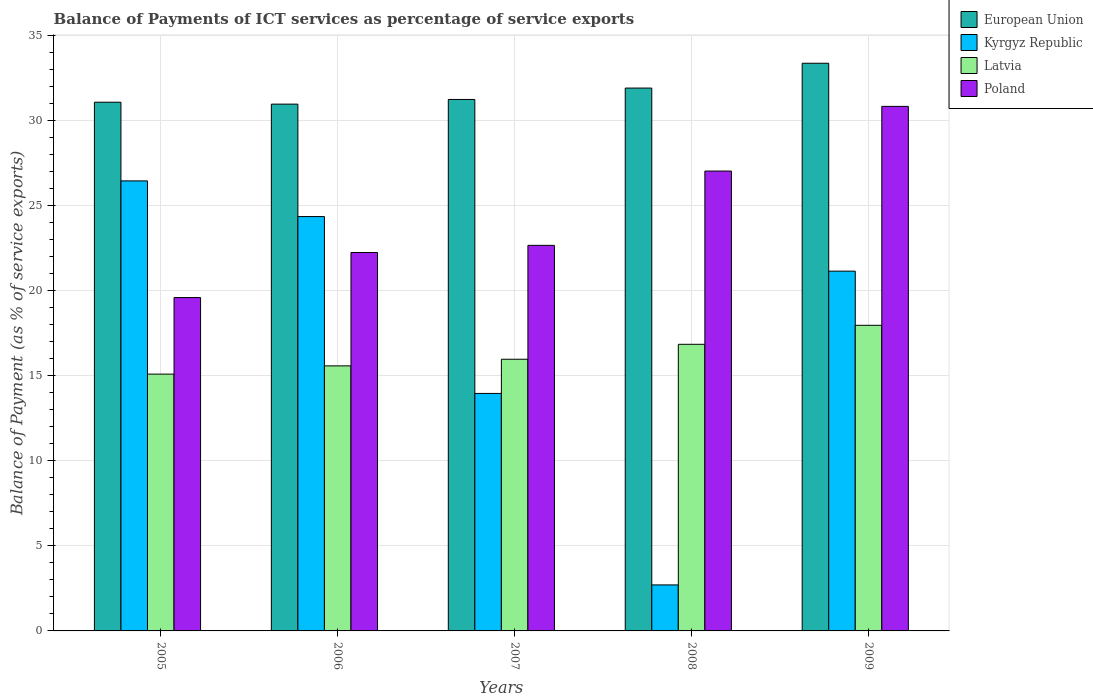How many groups of bars are there?
Make the answer very short. 5. Are the number of bars on each tick of the X-axis equal?
Ensure brevity in your answer.  Yes. How many bars are there on the 2nd tick from the left?
Your answer should be compact. 4. How many bars are there on the 1st tick from the right?
Give a very brief answer. 4. In how many cases, is the number of bars for a given year not equal to the number of legend labels?
Your answer should be compact. 0. What is the balance of payments of ICT services in European Union in 2007?
Your answer should be very brief. 31.23. Across all years, what is the maximum balance of payments of ICT services in Latvia?
Offer a very short reply. 17.96. Across all years, what is the minimum balance of payments of ICT services in Poland?
Offer a very short reply. 19.59. In which year was the balance of payments of ICT services in European Union maximum?
Ensure brevity in your answer.  2009. In which year was the balance of payments of ICT services in Poland minimum?
Provide a short and direct response. 2005. What is the total balance of payments of ICT services in European Union in the graph?
Your response must be concise. 158.52. What is the difference between the balance of payments of ICT services in European Union in 2006 and that in 2009?
Provide a short and direct response. -2.4. What is the difference between the balance of payments of ICT services in Kyrgyz Republic in 2008 and the balance of payments of ICT services in Poland in 2005?
Your answer should be very brief. -16.89. What is the average balance of payments of ICT services in Latvia per year?
Give a very brief answer. 16.29. In the year 2009, what is the difference between the balance of payments of ICT services in Kyrgyz Republic and balance of payments of ICT services in Latvia?
Your response must be concise. 3.18. What is the ratio of the balance of payments of ICT services in Latvia in 2006 to that in 2008?
Keep it short and to the point. 0.92. Is the balance of payments of ICT services in European Union in 2006 less than that in 2008?
Provide a succinct answer. Yes. Is the difference between the balance of payments of ICT services in Kyrgyz Republic in 2005 and 2007 greater than the difference between the balance of payments of ICT services in Latvia in 2005 and 2007?
Offer a very short reply. Yes. What is the difference between the highest and the second highest balance of payments of ICT services in Latvia?
Make the answer very short. 1.12. What is the difference between the highest and the lowest balance of payments of ICT services in Latvia?
Provide a short and direct response. 2.87. In how many years, is the balance of payments of ICT services in Latvia greater than the average balance of payments of ICT services in Latvia taken over all years?
Make the answer very short. 2. Is the sum of the balance of payments of ICT services in Latvia in 2005 and 2009 greater than the maximum balance of payments of ICT services in Kyrgyz Republic across all years?
Offer a terse response. Yes. What does the 2nd bar from the left in 2006 represents?
Your response must be concise. Kyrgyz Republic. How many years are there in the graph?
Your answer should be compact. 5. What is the difference between two consecutive major ticks on the Y-axis?
Offer a terse response. 5. Does the graph contain any zero values?
Keep it short and to the point. No. Where does the legend appear in the graph?
Make the answer very short. Top right. How are the legend labels stacked?
Make the answer very short. Vertical. What is the title of the graph?
Provide a short and direct response. Balance of Payments of ICT services as percentage of service exports. What is the label or title of the Y-axis?
Make the answer very short. Balance of Payment (as % of service exports). What is the Balance of Payment (as % of service exports) of European Union in 2005?
Ensure brevity in your answer.  31.07. What is the Balance of Payment (as % of service exports) of Kyrgyz Republic in 2005?
Your answer should be compact. 26.45. What is the Balance of Payment (as % of service exports) of Latvia in 2005?
Provide a succinct answer. 15.09. What is the Balance of Payment (as % of service exports) of Poland in 2005?
Offer a terse response. 19.59. What is the Balance of Payment (as % of service exports) of European Union in 2006?
Your answer should be compact. 30.96. What is the Balance of Payment (as % of service exports) in Kyrgyz Republic in 2006?
Offer a terse response. 24.35. What is the Balance of Payment (as % of service exports) of Latvia in 2006?
Give a very brief answer. 15.58. What is the Balance of Payment (as % of service exports) in Poland in 2006?
Provide a succinct answer. 22.24. What is the Balance of Payment (as % of service exports) of European Union in 2007?
Your answer should be compact. 31.23. What is the Balance of Payment (as % of service exports) of Kyrgyz Republic in 2007?
Keep it short and to the point. 13.96. What is the Balance of Payment (as % of service exports) in Latvia in 2007?
Offer a terse response. 15.97. What is the Balance of Payment (as % of service exports) of Poland in 2007?
Your answer should be compact. 22.66. What is the Balance of Payment (as % of service exports) in European Union in 2008?
Keep it short and to the point. 31.9. What is the Balance of Payment (as % of service exports) in Kyrgyz Republic in 2008?
Offer a very short reply. 2.7. What is the Balance of Payment (as % of service exports) of Latvia in 2008?
Your answer should be very brief. 16.84. What is the Balance of Payment (as % of service exports) in Poland in 2008?
Make the answer very short. 27.02. What is the Balance of Payment (as % of service exports) in European Union in 2009?
Provide a short and direct response. 33.36. What is the Balance of Payment (as % of service exports) in Kyrgyz Republic in 2009?
Provide a short and direct response. 21.14. What is the Balance of Payment (as % of service exports) in Latvia in 2009?
Provide a succinct answer. 17.96. What is the Balance of Payment (as % of service exports) in Poland in 2009?
Ensure brevity in your answer.  30.82. Across all years, what is the maximum Balance of Payment (as % of service exports) in European Union?
Keep it short and to the point. 33.36. Across all years, what is the maximum Balance of Payment (as % of service exports) in Kyrgyz Republic?
Provide a succinct answer. 26.45. Across all years, what is the maximum Balance of Payment (as % of service exports) in Latvia?
Keep it short and to the point. 17.96. Across all years, what is the maximum Balance of Payment (as % of service exports) of Poland?
Make the answer very short. 30.82. Across all years, what is the minimum Balance of Payment (as % of service exports) of European Union?
Offer a very short reply. 30.96. Across all years, what is the minimum Balance of Payment (as % of service exports) of Kyrgyz Republic?
Ensure brevity in your answer.  2.7. Across all years, what is the minimum Balance of Payment (as % of service exports) of Latvia?
Keep it short and to the point. 15.09. Across all years, what is the minimum Balance of Payment (as % of service exports) of Poland?
Offer a very short reply. 19.59. What is the total Balance of Payment (as % of service exports) of European Union in the graph?
Give a very brief answer. 158.52. What is the total Balance of Payment (as % of service exports) in Kyrgyz Republic in the graph?
Give a very brief answer. 88.6. What is the total Balance of Payment (as % of service exports) of Latvia in the graph?
Provide a succinct answer. 81.44. What is the total Balance of Payment (as % of service exports) in Poland in the graph?
Keep it short and to the point. 122.34. What is the difference between the Balance of Payment (as % of service exports) in European Union in 2005 and that in 2006?
Offer a very short reply. 0.11. What is the difference between the Balance of Payment (as % of service exports) in Kyrgyz Republic in 2005 and that in 2006?
Give a very brief answer. 2.1. What is the difference between the Balance of Payment (as % of service exports) in Latvia in 2005 and that in 2006?
Offer a very short reply. -0.48. What is the difference between the Balance of Payment (as % of service exports) in Poland in 2005 and that in 2006?
Your answer should be very brief. -2.65. What is the difference between the Balance of Payment (as % of service exports) in European Union in 2005 and that in 2007?
Your response must be concise. -0.16. What is the difference between the Balance of Payment (as % of service exports) in Kyrgyz Republic in 2005 and that in 2007?
Ensure brevity in your answer.  12.49. What is the difference between the Balance of Payment (as % of service exports) of Latvia in 2005 and that in 2007?
Ensure brevity in your answer.  -0.87. What is the difference between the Balance of Payment (as % of service exports) of Poland in 2005 and that in 2007?
Your answer should be very brief. -3.07. What is the difference between the Balance of Payment (as % of service exports) of European Union in 2005 and that in 2008?
Provide a succinct answer. -0.83. What is the difference between the Balance of Payment (as % of service exports) of Kyrgyz Republic in 2005 and that in 2008?
Ensure brevity in your answer.  23.74. What is the difference between the Balance of Payment (as % of service exports) of Latvia in 2005 and that in 2008?
Make the answer very short. -1.75. What is the difference between the Balance of Payment (as % of service exports) of Poland in 2005 and that in 2008?
Give a very brief answer. -7.43. What is the difference between the Balance of Payment (as % of service exports) in European Union in 2005 and that in 2009?
Provide a short and direct response. -2.29. What is the difference between the Balance of Payment (as % of service exports) of Kyrgyz Republic in 2005 and that in 2009?
Your answer should be very brief. 5.3. What is the difference between the Balance of Payment (as % of service exports) of Latvia in 2005 and that in 2009?
Provide a succinct answer. -2.87. What is the difference between the Balance of Payment (as % of service exports) of Poland in 2005 and that in 2009?
Your response must be concise. -11.23. What is the difference between the Balance of Payment (as % of service exports) in European Union in 2006 and that in 2007?
Keep it short and to the point. -0.27. What is the difference between the Balance of Payment (as % of service exports) in Kyrgyz Republic in 2006 and that in 2007?
Give a very brief answer. 10.39. What is the difference between the Balance of Payment (as % of service exports) in Latvia in 2006 and that in 2007?
Offer a very short reply. -0.39. What is the difference between the Balance of Payment (as % of service exports) in Poland in 2006 and that in 2007?
Ensure brevity in your answer.  -0.42. What is the difference between the Balance of Payment (as % of service exports) in European Union in 2006 and that in 2008?
Ensure brevity in your answer.  -0.94. What is the difference between the Balance of Payment (as % of service exports) in Kyrgyz Republic in 2006 and that in 2008?
Make the answer very short. 21.65. What is the difference between the Balance of Payment (as % of service exports) of Latvia in 2006 and that in 2008?
Make the answer very short. -1.27. What is the difference between the Balance of Payment (as % of service exports) of Poland in 2006 and that in 2008?
Provide a succinct answer. -4.79. What is the difference between the Balance of Payment (as % of service exports) of European Union in 2006 and that in 2009?
Your answer should be very brief. -2.4. What is the difference between the Balance of Payment (as % of service exports) of Kyrgyz Republic in 2006 and that in 2009?
Provide a short and direct response. 3.21. What is the difference between the Balance of Payment (as % of service exports) in Latvia in 2006 and that in 2009?
Give a very brief answer. -2.38. What is the difference between the Balance of Payment (as % of service exports) in Poland in 2006 and that in 2009?
Provide a short and direct response. -8.59. What is the difference between the Balance of Payment (as % of service exports) of European Union in 2007 and that in 2008?
Give a very brief answer. -0.67. What is the difference between the Balance of Payment (as % of service exports) in Kyrgyz Republic in 2007 and that in 2008?
Give a very brief answer. 11.25. What is the difference between the Balance of Payment (as % of service exports) of Latvia in 2007 and that in 2008?
Ensure brevity in your answer.  -0.88. What is the difference between the Balance of Payment (as % of service exports) in Poland in 2007 and that in 2008?
Give a very brief answer. -4.37. What is the difference between the Balance of Payment (as % of service exports) of European Union in 2007 and that in 2009?
Your answer should be very brief. -2.13. What is the difference between the Balance of Payment (as % of service exports) of Kyrgyz Republic in 2007 and that in 2009?
Offer a terse response. -7.19. What is the difference between the Balance of Payment (as % of service exports) of Latvia in 2007 and that in 2009?
Your answer should be compact. -1.99. What is the difference between the Balance of Payment (as % of service exports) in Poland in 2007 and that in 2009?
Offer a very short reply. -8.17. What is the difference between the Balance of Payment (as % of service exports) in European Union in 2008 and that in 2009?
Give a very brief answer. -1.46. What is the difference between the Balance of Payment (as % of service exports) of Kyrgyz Republic in 2008 and that in 2009?
Your response must be concise. -18.44. What is the difference between the Balance of Payment (as % of service exports) in Latvia in 2008 and that in 2009?
Keep it short and to the point. -1.12. What is the difference between the Balance of Payment (as % of service exports) in Poland in 2008 and that in 2009?
Offer a very short reply. -3.8. What is the difference between the Balance of Payment (as % of service exports) of European Union in 2005 and the Balance of Payment (as % of service exports) of Kyrgyz Republic in 2006?
Make the answer very short. 6.72. What is the difference between the Balance of Payment (as % of service exports) in European Union in 2005 and the Balance of Payment (as % of service exports) in Latvia in 2006?
Make the answer very short. 15.49. What is the difference between the Balance of Payment (as % of service exports) in European Union in 2005 and the Balance of Payment (as % of service exports) in Poland in 2006?
Ensure brevity in your answer.  8.83. What is the difference between the Balance of Payment (as % of service exports) of Kyrgyz Republic in 2005 and the Balance of Payment (as % of service exports) of Latvia in 2006?
Offer a very short reply. 10.87. What is the difference between the Balance of Payment (as % of service exports) of Kyrgyz Republic in 2005 and the Balance of Payment (as % of service exports) of Poland in 2006?
Provide a succinct answer. 4.21. What is the difference between the Balance of Payment (as % of service exports) in Latvia in 2005 and the Balance of Payment (as % of service exports) in Poland in 2006?
Provide a succinct answer. -7.15. What is the difference between the Balance of Payment (as % of service exports) of European Union in 2005 and the Balance of Payment (as % of service exports) of Kyrgyz Republic in 2007?
Provide a succinct answer. 17.11. What is the difference between the Balance of Payment (as % of service exports) of European Union in 2005 and the Balance of Payment (as % of service exports) of Latvia in 2007?
Offer a very short reply. 15.1. What is the difference between the Balance of Payment (as % of service exports) of European Union in 2005 and the Balance of Payment (as % of service exports) of Poland in 2007?
Ensure brevity in your answer.  8.41. What is the difference between the Balance of Payment (as % of service exports) of Kyrgyz Republic in 2005 and the Balance of Payment (as % of service exports) of Latvia in 2007?
Provide a succinct answer. 10.48. What is the difference between the Balance of Payment (as % of service exports) of Kyrgyz Republic in 2005 and the Balance of Payment (as % of service exports) of Poland in 2007?
Provide a short and direct response. 3.79. What is the difference between the Balance of Payment (as % of service exports) in Latvia in 2005 and the Balance of Payment (as % of service exports) in Poland in 2007?
Your answer should be very brief. -7.57. What is the difference between the Balance of Payment (as % of service exports) in European Union in 2005 and the Balance of Payment (as % of service exports) in Kyrgyz Republic in 2008?
Provide a short and direct response. 28.37. What is the difference between the Balance of Payment (as % of service exports) of European Union in 2005 and the Balance of Payment (as % of service exports) of Latvia in 2008?
Provide a short and direct response. 14.23. What is the difference between the Balance of Payment (as % of service exports) in European Union in 2005 and the Balance of Payment (as % of service exports) in Poland in 2008?
Provide a succinct answer. 4.05. What is the difference between the Balance of Payment (as % of service exports) in Kyrgyz Republic in 2005 and the Balance of Payment (as % of service exports) in Latvia in 2008?
Your response must be concise. 9.6. What is the difference between the Balance of Payment (as % of service exports) of Kyrgyz Republic in 2005 and the Balance of Payment (as % of service exports) of Poland in 2008?
Offer a terse response. -0.58. What is the difference between the Balance of Payment (as % of service exports) of Latvia in 2005 and the Balance of Payment (as % of service exports) of Poland in 2008?
Your answer should be very brief. -11.93. What is the difference between the Balance of Payment (as % of service exports) in European Union in 2005 and the Balance of Payment (as % of service exports) in Kyrgyz Republic in 2009?
Offer a very short reply. 9.93. What is the difference between the Balance of Payment (as % of service exports) of European Union in 2005 and the Balance of Payment (as % of service exports) of Latvia in 2009?
Offer a terse response. 13.11. What is the difference between the Balance of Payment (as % of service exports) in European Union in 2005 and the Balance of Payment (as % of service exports) in Poland in 2009?
Provide a short and direct response. 0.25. What is the difference between the Balance of Payment (as % of service exports) of Kyrgyz Republic in 2005 and the Balance of Payment (as % of service exports) of Latvia in 2009?
Offer a terse response. 8.49. What is the difference between the Balance of Payment (as % of service exports) of Kyrgyz Republic in 2005 and the Balance of Payment (as % of service exports) of Poland in 2009?
Provide a short and direct response. -4.38. What is the difference between the Balance of Payment (as % of service exports) in Latvia in 2005 and the Balance of Payment (as % of service exports) in Poland in 2009?
Ensure brevity in your answer.  -15.73. What is the difference between the Balance of Payment (as % of service exports) in European Union in 2006 and the Balance of Payment (as % of service exports) in Kyrgyz Republic in 2007?
Your response must be concise. 17. What is the difference between the Balance of Payment (as % of service exports) in European Union in 2006 and the Balance of Payment (as % of service exports) in Latvia in 2007?
Ensure brevity in your answer.  14.99. What is the difference between the Balance of Payment (as % of service exports) in European Union in 2006 and the Balance of Payment (as % of service exports) in Poland in 2007?
Make the answer very short. 8.3. What is the difference between the Balance of Payment (as % of service exports) of Kyrgyz Republic in 2006 and the Balance of Payment (as % of service exports) of Latvia in 2007?
Provide a short and direct response. 8.38. What is the difference between the Balance of Payment (as % of service exports) of Kyrgyz Republic in 2006 and the Balance of Payment (as % of service exports) of Poland in 2007?
Ensure brevity in your answer.  1.69. What is the difference between the Balance of Payment (as % of service exports) of Latvia in 2006 and the Balance of Payment (as % of service exports) of Poland in 2007?
Ensure brevity in your answer.  -7.08. What is the difference between the Balance of Payment (as % of service exports) of European Union in 2006 and the Balance of Payment (as % of service exports) of Kyrgyz Republic in 2008?
Make the answer very short. 28.25. What is the difference between the Balance of Payment (as % of service exports) of European Union in 2006 and the Balance of Payment (as % of service exports) of Latvia in 2008?
Your answer should be compact. 14.11. What is the difference between the Balance of Payment (as % of service exports) in European Union in 2006 and the Balance of Payment (as % of service exports) in Poland in 2008?
Offer a very short reply. 3.93. What is the difference between the Balance of Payment (as % of service exports) of Kyrgyz Republic in 2006 and the Balance of Payment (as % of service exports) of Latvia in 2008?
Provide a short and direct response. 7.51. What is the difference between the Balance of Payment (as % of service exports) of Kyrgyz Republic in 2006 and the Balance of Payment (as % of service exports) of Poland in 2008?
Your response must be concise. -2.68. What is the difference between the Balance of Payment (as % of service exports) in Latvia in 2006 and the Balance of Payment (as % of service exports) in Poland in 2008?
Ensure brevity in your answer.  -11.45. What is the difference between the Balance of Payment (as % of service exports) of European Union in 2006 and the Balance of Payment (as % of service exports) of Kyrgyz Republic in 2009?
Keep it short and to the point. 9.81. What is the difference between the Balance of Payment (as % of service exports) of European Union in 2006 and the Balance of Payment (as % of service exports) of Latvia in 2009?
Offer a terse response. 13. What is the difference between the Balance of Payment (as % of service exports) in European Union in 2006 and the Balance of Payment (as % of service exports) in Poland in 2009?
Provide a succinct answer. 0.13. What is the difference between the Balance of Payment (as % of service exports) in Kyrgyz Republic in 2006 and the Balance of Payment (as % of service exports) in Latvia in 2009?
Your response must be concise. 6.39. What is the difference between the Balance of Payment (as % of service exports) in Kyrgyz Republic in 2006 and the Balance of Payment (as % of service exports) in Poland in 2009?
Give a very brief answer. -6.48. What is the difference between the Balance of Payment (as % of service exports) in Latvia in 2006 and the Balance of Payment (as % of service exports) in Poland in 2009?
Provide a succinct answer. -15.25. What is the difference between the Balance of Payment (as % of service exports) in European Union in 2007 and the Balance of Payment (as % of service exports) in Kyrgyz Republic in 2008?
Provide a short and direct response. 28.53. What is the difference between the Balance of Payment (as % of service exports) of European Union in 2007 and the Balance of Payment (as % of service exports) of Latvia in 2008?
Make the answer very short. 14.39. What is the difference between the Balance of Payment (as % of service exports) in European Union in 2007 and the Balance of Payment (as % of service exports) in Poland in 2008?
Provide a short and direct response. 4.21. What is the difference between the Balance of Payment (as % of service exports) in Kyrgyz Republic in 2007 and the Balance of Payment (as % of service exports) in Latvia in 2008?
Offer a terse response. -2.89. What is the difference between the Balance of Payment (as % of service exports) of Kyrgyz Republic in 2007 and the Balance of Payment (as % of service exports) of Poland in 2008?
Provide a succinct answer. -13.07. What is the difference between the Balance of Payment (as % of service exports) of Latvia in 2007 and the Balance of Payment (as % of service exports) of Poland in 2008?
Your response must be concise. -11.06. What is the difference between the Balance of Payment (as % of service exports) of European Union in 2007 and the Balance of Payment (as % of service exports) of Kyrgyz Republic in 2009?
Give a very brief answer. 10.09. What is the difference between the Balance of Payment (as % of service exports) of European Union in 2007 and the Balance of Payment (as % of service exports) of Latvia in 2009?
Provide a succinct answer. 13.27. What is the difference between the Balance of Payment (as % of service exports) in European Union in 2007 and the Balance of Payment (as % of service exports) in Poland in 2009?
Ensure brevity in your answer.  0.41. What is the difference between the Balance of Payment (as % of service exports) of Kyrgyz Republic in 2007 and the Balance of Payment (as % of service exports) of Latvia in 2009?
Offer a very short reply. -4. What is the difference between the Balance of Payment (as % of service exports) in Kyrgyz Republic in 2007 and the Balance of Payment (as % of service exports) in Poland in 2009?
Give a very brief answer. -16.87. What is the difference between the Balance of Payment (as % of service exports) of Latvia in 2007 and the Balance of Payment (as % of service exports) of Poland in 2009?
Your answer should be very brief. -14.86. What is the difference between the Balance of Payment (as % of service exports) of European Union in 2008 and the Balance of Payment (as % of service exports) of Kyrgyz Republic in 2009?
Ensure brevity in your answer.  10.76. What is the difference between the Balance of Payment (as % of service exports) of European Union in 2008 and the Balance of Payment (as % of service exports) of Latvia in 2009?
Provide a succinct answer. 13.94. What is the difference between the Balance of Payment (as % of service exports) of European Union in 2008 and the Balance of Payment (as % of service exports) of Poland in 2009?
Offer a very short reply. 1.08. What is the difference between the Balance of Payment (as % of service exports) in Kyrgyz Republic in 2008 and the Balance of Payment (as % of service exports) in Latvia in 2009?
Your answer should be compact. -15.26. What is the difference between the Balance of Payment (as % of service exports) of Kyrgyz Republic in 2008 and the Balance of Payment (as % of service exports) of Poland in 2009?
Ensure brevity in your answer.  -28.12. What is the difference between the Balance of Payment (as % of service exports) of Latvia in 2008 and the Balance of Payment (as % of service exports) of Poland in 2009?
Provide a short and direct response. -13.98. What is the average Balance of Payment (as % of service exports) of European Union per year?
Your answer should be very brief. 31.7. What is the average Balance of Payment (as % of service exports) of Kyrgyz Republic per year?
Your answer should be very brief. 17.72. What is the average Balance of Payment (as % of service exports) of Latvia per year?
Provide a short and direct response. 16.29. What is the average Balance of Payment (as % of service exports) of Poland per year?
Your answer should be compact. 24.47. In the year 2005, what is the difference between the Balance of Payment (as % of service exports) in European Union and Balance of Payment (as % of service exports) in Kyrgyz Republic?
Your response must be concise. 4.62. In the year 2005, what is the difference between the Balance of Payment (as % of service exports) of European Union and Balance of Payment (as % of service exports) of Latvia?
Your answer should be very brief. 15.98. In the year 2005, what is the difference between the Balance of Payment (as % of service exports) in European Union and Balance of Payment (as % of service exports) in Poland?
Offer a very short reply. 11.48. In the year 2005, what is the difference between the Balance of Payment (as % of service exports) of Kyrgyz Republic and Balance of Payment (as % of service exports) of Latvia?
Ensure brevity in your answer.  11.35. In the year 2005, what is the difference between the Balance of Payment (as % of service exports) of Kyrgyz Republic and Balance of Payment (as % of service exports) of Poland?
Keep it short and to the point. 6.86. In the year 2005, what is the difference between the Balance of Payment (as % of service exports) of Latvia and Balance of Payment (as % of service exports) of Poland?
Your answer should be very brief. -4.5. In the year 2006, what is the difference between the Balance of Payment (as % of service exports) of European Union and Balance of Payment (as % of service exports) of Kyrgyz Republic?
Provide a succinct answer. 6.61. In the year 2006, what is the difference between the Balance of Payment (as % of service exports) of European Union and Balance of Payment (as % of service exports) of Latvia?
Offer a terse response. 15.38. In the year 2006, what is the difference between the Balance of Payment (as % of service exports) in European Union and Balance of Payment (as % of service exports) in Poland?
Provide a succinct answer. 8.72. In the year 2006, what is the difference between the Balance of Payment (as % of service exports) in Kyrgyz Republic and Balance of Payment (as % of service exports) in Latvia?
Keep it short and to the point. 8.77. In the year 2006, what is the difference between the Balance of Payment (as % of service exports) of Kyrgyz Republic and Balance of Payment (as % of service exports) of Poland?
Ensure brevity in your answer.  2.11. In the year 2006, what is the difference between the Balance of Payment (as % of service exports) of Latvia and Balance of Payment (as % of service exports) of Poland?
Your answer should be compact. -6.66. In the year 2007, what is the difference between the Balance of Payment (as % of service exports) of European Union and Balance of Payment (as % of service exports) of Kyrgyz Republic?
Your answer should be very brief. 17.27. In the year 2007, what is the difference between the Balance of Payment (as % of service exports) of European Union and Balance of Payment (as % of service exports) of Latvia?
Offer a very short reply. 15.27. In the year 2007, what is the difference between the Balance of Payment (as % of service exports) in European Union and Balance of Payment (as % of service exports) in Poland?
Your answer should be compact. 8.57. In the year 2007, what is the difference between the Balance of Payment (as % of service exports) in Kyrgyz Republic and Balance of Payment (as % of service exports) in Latvia?
Your answer should be compact. -2.01. In the year 2007, what is the difference between the Balance of Payment (as % of service exports) in Kyrgyz Republic and Balance of Payment (as % of service exports) in Poland?
Give a very brief answer. -8.7. In the year 2007, what is the difference between the Balance of Payment (as % of service exports) of Latvia and Balance of Payment (as % of service exports) of Poland?
Ensure brevity in your answer.  -6.69. In the year 2008, what is the difference between the Balance of Payment (as % of service exports) of European Union and Balance of Payment (as % of service exports) of Kyrgyz Republic?
Provide a succinct answer. 29.2. In the year 2008, what is the difference between the Balance of Payment (as % of service exports) of European Union and Balance of Payment (as % of service exports) of Latvia?
Your answer should be very brief. 15.06. In the year 2008, what is the difference between the Balance of Payment (as % of service exports) in European Union and Balance of Payment (as % of service exports) in Poland?
Ensure brevity in your answer.  4.88. In the year 2008, what is the difference between the Balance of Payment (as % of service exports) of Kyrgyz Republic and Balance of Payment (as % of service exports) of Latvia?
Make the answer very short. -14.14. In the year 2008, what is the difference between the Balance of Payment (as % of service exports) of Kyrgyz Republic and Balance of Payment (as % of service exports) of Poland?
Your response must be concise. -24.32. In the year 2008, what is the difference between the Balance of Payment (as % of service exports) in Latvia and Balance of Payment (as % of service exports) in Poland?
Make the answer very short. -10.18. In the year 2009, what is the difference between the Balance of Payment (as % of service exports) in European Union and Balance of Payment (as % of service exports) in Kyrgyz Republic?
Offer a very short reply. 12.22. In the year 2009, what is the difference between the Balance of Payment (as % of service exports) in European Union and Balance of Payment (as % of service exports) in Latvia?
Give a very brief answer. 15.4. In the year 2009, what is the difference between the Balance of Payment (as % of service exports) in European Union and Balance of Payment (as % of service exports) in Poland?
Offer a very short reply. 2.53. In the year 2009, what is the difference between the Balance of Payment (as % of service exports) in Kyrgyz Republic and Balance of Payment (as % of service exports) in Latvia?
Keep it short and to the point. 3.18. In the year 2009, what is the difference between the Balance of Payment (as % of service exports) in Kyrgyz Republic and Balance of Payment (as % of service exports) in Poland?
Give a very brief answer. -9.68. In the year 2009, what is the difference between the Balance of Payment (as % of service exports) in Latvia and Balance of Payment (as % of service exports) in Poland?
Give a very brief answer. -12.86. What is the ratio of the Balance of Payment (as % of service exports) in Kyrgyz Republic in 2005 to that in 2006?
Offer a terse response. 1.09. What is the ratio of the Balance of Payment (as % of service exports) in Latvia in 2005 to that in 2006?
Offer a terse response. 0.97. What is the ratio of the Balance of Payment (as % of service exports) in Poland in 2005 to that in 2006?
Give a very brief answer. 0.88. What is the ratio of the Balance of Payment (as % of service exports) of Kyrgyz Republic in 2005 to that in 2007?
Provide a short and direct response. 1.89. What is the ratio of the Balance of Payment (as % of service exports) of Latvia in 2005 to that in 2007?
Your response must be concise. 0.95. What is the ratio of the Balance of Payment (as % of service exports) in Poland in 2005 to that in 2007?
Provide a short and direct response. 0.86. What is the ratio of the Balance of Payment (as % of service exports) of Kyrgyz Republic in 2005 to that in 2008?
Offer a terse response. 9.78. What is the ratio of the Balance of Payment (as % of service exports) of Latvia in 2005 to that in 2008?
Keep it short and to the point. 0.9. What is the ratio of the Balance of Payment (as % of service exports) of Poland in 2005 to that in 2008?
Provide a succinct answer. 0.72. What is the ratio of the Balance of Payment (as % of service exports) in European Union in 2005 to that in 2009?
Offer a terse response. 0.93. What is the ratio of the Balance of Payment (as % of service exports) of Kyrgyz Republic in 2005 to that in 2009?
Offer a terse response. 1.25. What is the ratio of the Balance of Payment (as % of service exports) in Latvia in 2005 to that in 2009?
Your answer should be compact. 0.84. What is the ratio of the Balance of Payment (as % of service exports) of Poland in 2005 to that in 2009?
Your response must be concise. 0.64. What is the ratio of the Balance of Payment (as % of service exports) in Kyrgyz Republic in 2006 to that in 2007?
Your response must be concise. 1.74. What is the ratio of the Balance of Payment (as % of service exports) of Latvia in 2006 to that in 2007?
Offer a very short reply. 0.98. What is the ratio of the Balance of Payment (as % of service exports) in Poland in 2006 to that in 2007?
Provide a short and direct response. 0.98. What is the ratio of the Balance of Payment (as % of service exports) of European Union in 2006 to that in 2008?
Your response must be concise. 0.97. What is the ratio of the Balance of Payment (as % of service exports) of Kyrgyz Republic in 2006 to that in 2008?
Offer a very short reply. 9.01. What is the ratio of the Balance of Payment (as % of service exports) of Latvia in 2006 to that in 2008?
Provide a short and direct response. 0.92. What is the ratio of the Balance of Payment (as % of service exports) in Poland in 2006 to that in 2008?
Provide a short and direct response. 0.82. What is the ratio of the Balance of Payment (as % of service exports) in European Union in 2006 to that in 2009?
Ensure brevity in your answer.  0.93. What is the ratio of the Balance of Payment (as % of service exports) of Kyrgyz Republic in 2006 to that in 2009?
Give a very brief answer. 1.15. What is the ratio of the Balance of Payment (as % of service exports) in Latvia in 2006 to that in 2009?
Make the answer very short. 0.87. What is the ratio of the Balance of Payment (as % of service exports) in Poland in 2006 to that in 2009?
Ensure brevity in your answer.  0.72. What is the ratio of the Balance of Payment (as % of service exports) in European Union in 2007 to that in 2008?
Your answer should be very brief. 0.98. What is the ratio of the Balance of Payment (as % of service exports) of Kyrgyz Republic in 2007 to that in 2008?
Provide a short and direct response. 5.16. What is the ratio of the Balance of Payment (as % of service exports) in Latvia in 2007 to that in 2008?
Provide a short and direct response. 0.95. What is the ratio of the Balance of Payment (as % of service exports) of Poland in 2007 to that in 2008?
Make the answer very short. 0.84. What is the ratio of the Balance of Payment (as % of service exports) in European Union in 2007 to that in 2009?
Give a very brief answer. 0.94. What is the ratio of the Balance of Payment (as % of service exports) of Kyrgyz Republic in 2007 to that in 2009?
Make the answer very short. 0.66. What is the ratio of the Balance of Payment (as % of service exports) of Poland in 2007 to that in 2009?
Give a very brief answer. 0.74. What is the ratio of the Balance of Payment (as % of service exports) of European Union in 2008 to that in 2009?
Provide a short and direct response. 0.96. What is the ratio of the Balance of Payment (as % of service exports) in Kyrgyz Republic in 2008 to that in 2009?
Make the answer very short. 0.13. What is the ratio of the Balance of Payment (as % of service exports) in Latvia in 2008 to that in 2009?
Your answer should be very brief. 0.94. What is the ratio of the Balance of Payment (as % of service exports) in Poland in 2008 to that in 2009?
Give a very brief answer. 0.88. What is the difference between the highest and the second highest Balance of Payment (as % of service exports) in European Union?
Provide a short and direct response. 1.46. What is the difference between the highest and the second highest Balance of Payment (as % of service exports) in Kyrgyz Republic?
Offer a very short reply. 2.1. What is the difference between the highest and the second highest Balance of Payment (as % of service exports) of Latvia?
Make the answer very short. 1.12. What is the difference between the highest and the second highest Balance of Payment (as % of service exports) of Poland?
Make the answer very short. 3.8. What is the difference between the highest and the lowest Balance of Payment (as % of service exports) in European Union?
Provide a succinct answer. 2.4. What is the difference between the highest and the lowest Balance of Payment (as % of service exports) in Kyrgyz Republic?
Provide a short and direct response. 23.74. What is the difference between the highest and the lowest Balance of Payment (as % of service exports) in Latvia?
Your answer should be compact. 2.87. What is the difference between the highest and the lowest Balance of Payment (as % of service exports) in Poland?
Your answer should be very brief. 11.23. 